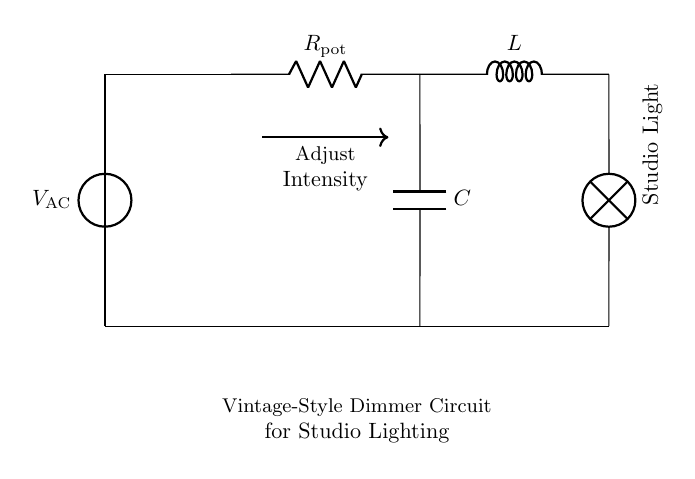What type of circuit is this? This circuit is a Resistor-Inductor-Capacitor (RLC) circuit, characterized by the inclusion of a resistor, inductor, and capacitor connected in a certain configuration.
Answer: RLC What component is used to adjust the intensity? The component used to adjust the intensity of the studio lighting is the variable resistor (potentiometer) labeled as "R pot" in the diagram.
Answer: R pot What does the inductor do in this circuit? The inductor in this circuit works to store energy in a magnetic field and aids in controlling current flow, which can help smooth out the changes in the current when the potentiometer is adjusted.
Answer: Control current What is the primary function of the capacitor in this circuit? The capacitor's primary function is to store and release electrical energy, thereby affecting the overall timing and smoothing of the voltage across the studio light, which ultimately influences the light's brightness.
Answer: Smooth voltage How is the studio light powered in this circuit? The studio light is powered by an alternating current (AC) supply, represented by the voltage source labeled "V AC," which provides the necessary power for the light to function.
Answer: V AC What happens when the potentiometer is turned? When the potentiometer is turned, it changes the resistance in the circuit, which affects the current flowing to the lamp and thus alters the intensity of the studio light.
Answer: Adjust intensity What is the purpose of connecting the capacitor in parallel with the inductor? The connection of the capacitor in parallel with the inductor helps to create a resonant circuit which can enhance the quality of current supplied to the studio light, allowing for better control of voltage and current fluctuations.
Answer: Enhance control 